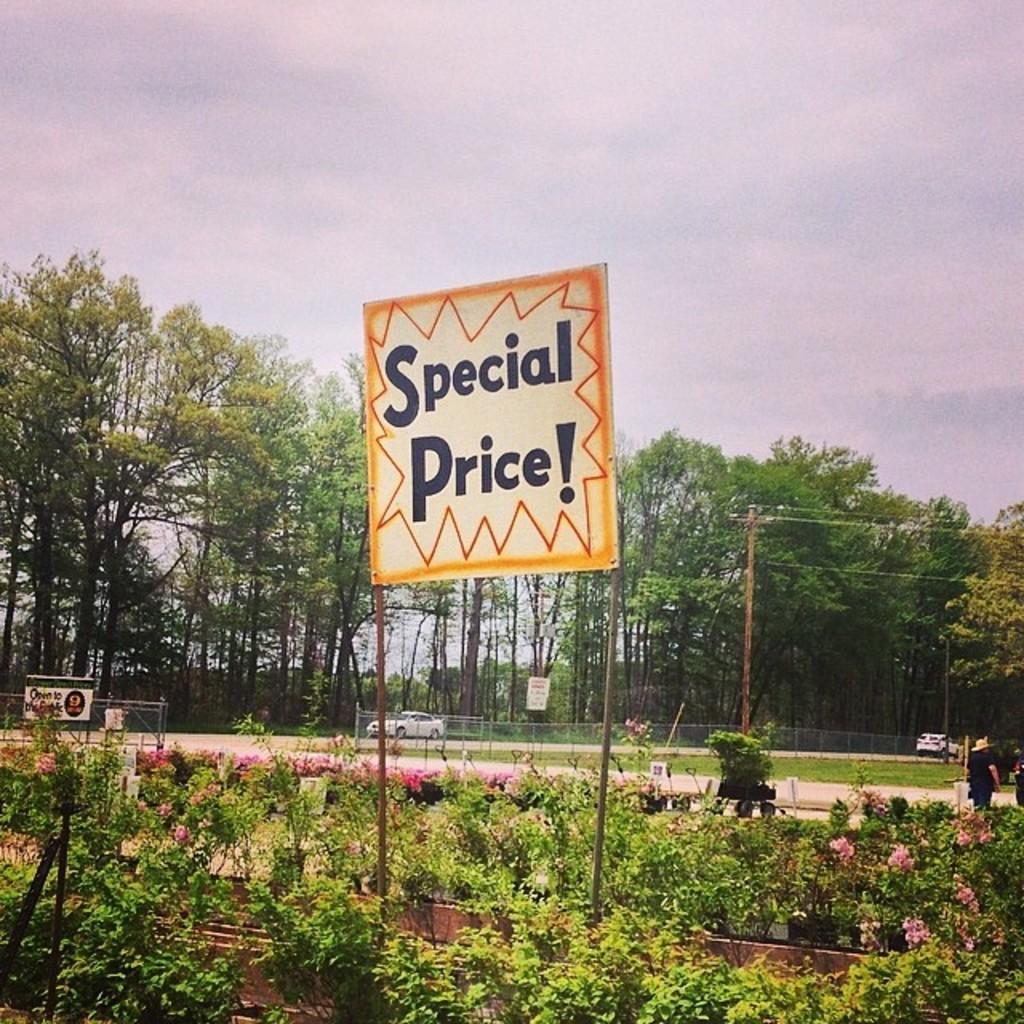Can you describe this image briefly? This is the name board, which is attached to the poles. These are the plants with flowers. I can see two cars on the road. These are the trees. This looks like a current pole with current wires. At the right corner of the image, I can see a person standing. 